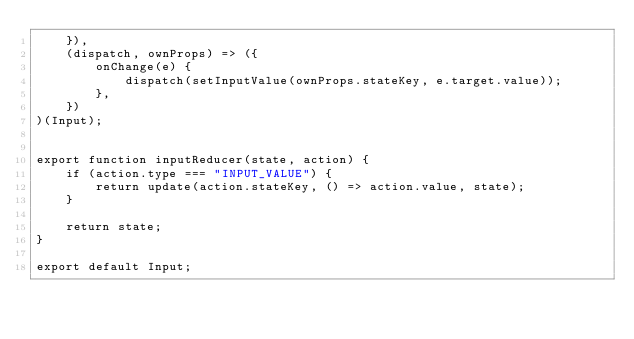<code> <loc_0><loc_0><loc_500><loc_500><_JavaScript_>    }),
    (dispatch, ownProps) => ({
        onChange(e) {
            dispatch(setInputValue(ownProps.stateKey, e.target.value));
        },
    })
)(Input);


export function inputReducer(state, action) {
    if (action.type === "INPUT_VALUE") {
        return update(action.stateKey, () => action.value, state);
    }

    return state;
}

export default Input;
</code> 